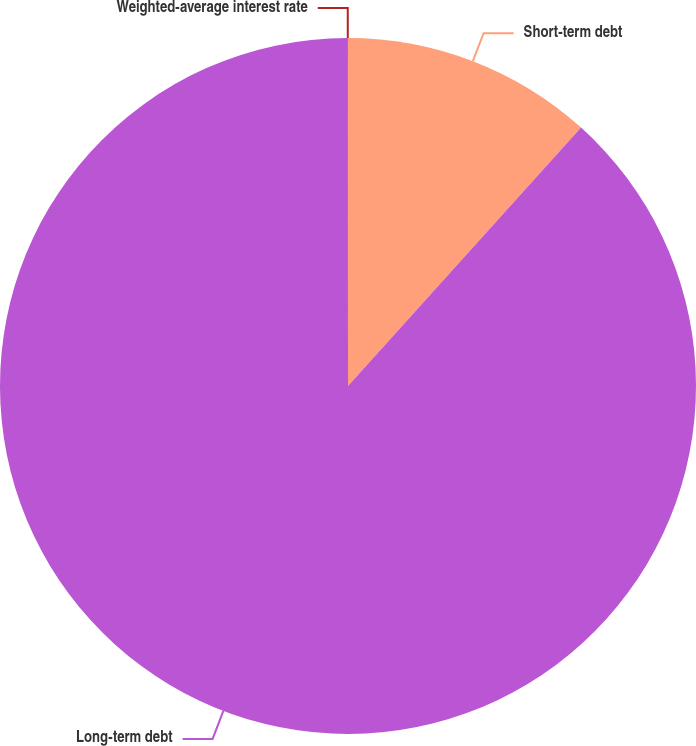<chart> <loc_0><loc_0><loc_500><loc_500><pie_chart><fcel>Short-term debt<fcel>Long-term debt<fcel>Weighted-average interest rate<nl><fcel>11.68%<fcel>88.3%<fcel>0.02%<nl></chart> 